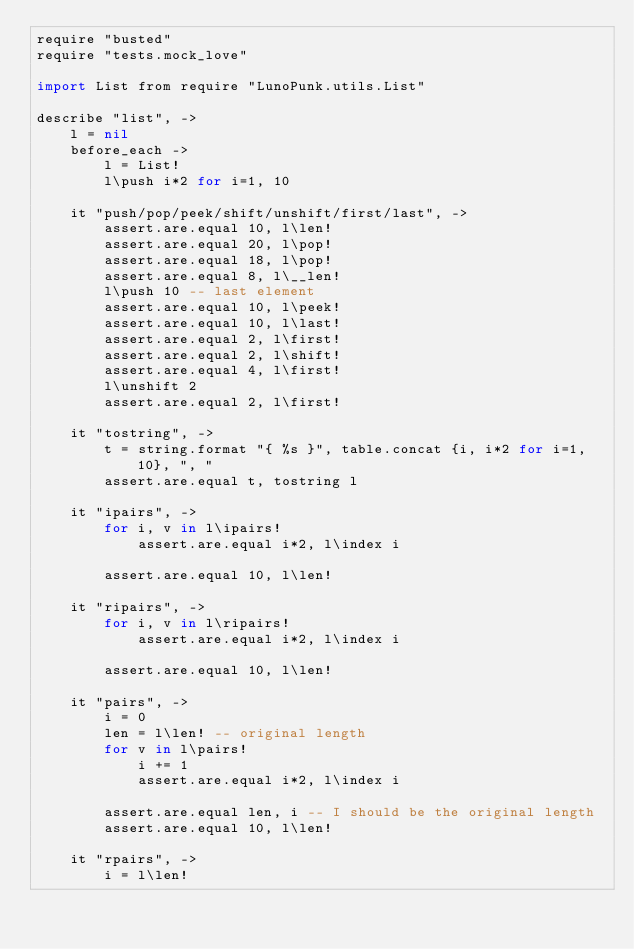Convert code to text. <code><loc_0><loc_0><loc_500><loc_500><_MoonScript_>require "busted"
require "tests.mock_love"

import List from require "LunoPunk.utils.List"

describe "list", ->
	l = nil
	before_each ->
		l = List!
		l\push i*2 for i=1, 10

	it "push/pop/peek/shift/unshift/first/last", ->
		assert.are.equal 10, l\len!
		assert.are.equal 20, l\pop!
		assert.are.equal 18, l\pop!
		assert.are.equal 8, l\__len!
		l\push 10 -- last element
		assert.are.equal 10, l\peek!
		assert.are.equal 10, l\last!
		assert.are.equal 2, l\first!
		assert.are.equal 2, l\shift!
		assert.are.equal 4, l\first!
		l\unshift 2
		assert.are.equal 2, l\first!

	it "tostring", ->
		t = string.format "{ %s }", table.concat {i, i*2 for i=1, 10}, ", "
		assert.are.equal t, tostring l

	it "ipairs", ->
		for i, v in l\ipairs!
			assert.are.equal i*2, l\index i

		assert.are.equal 10, l\len!

	it "ripairs", ->
		for i, v in l\ripairs!
			assert.are.equal i*2, l\index i

		assert.are.equal 10, l\len!

	it "pairs", ->
		i = 0
		len = l\len! -- original length
		for v in l\pairs!
			i += 1
			assert.are.equal i*2, l\index i

		assert.are.equal len, i -- I should be the original length
		assert.are.equal 10, l\len!

	it "rpairs", ->
		i = l\len!</code> 